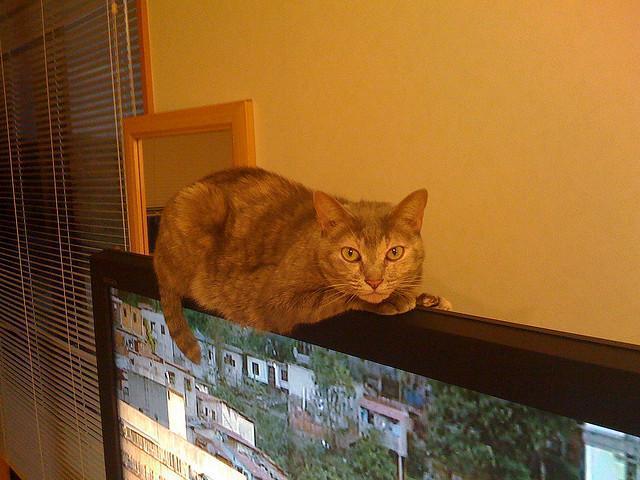How many cats do you see?
Give a very brief answer. 1. 